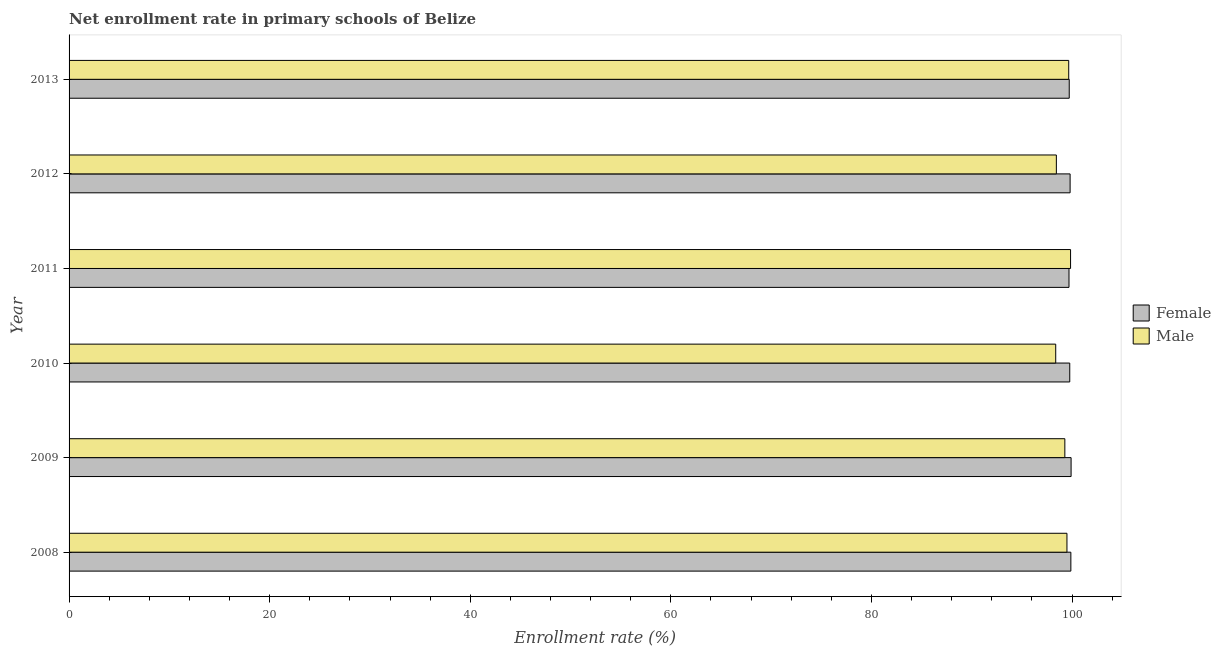How many bars are there on the 2nd tick from the top?
Keep it short and to the point. 2. What is the enrollment rate of male students in 2012?
Your response must be concise. 98.44. Across all years, what is the maximum enrollment rate of male students?
Ensure brevity in your answer.  99.85. Across all years, what is the minimum enrollment rate of male students?
Your answer should be compact. 98.37. In which year was the enrollment rate of female students maximum?
Provide a succinct answer. 2009. What is the total enrollment rate of female students in the graph?
Offer a very short reply. 598.79. What is the difference between the enrollment rate of female students in 2009 and that in 2012?
Offer a very short reply. 0.1. What is the difference between the enrollment rate of female students in 2010 and the enrollment rate of male students in 2008?
Your answer should be very brief. 0.28. What is the average enrollment rate of female students per year?
Your answer should be compact. 99.8. What is the ratio of the enrollment rate of male students in 2008 to that in 2013?
Your answer should be very brief. 1. Is the enrollment rate of male students in 2011 less than that in 2012?
Keep it short and to the point. No. What is the difference between the highest and the second highest enrollment rate of male students?
Offer a terse response. 0.18. What is the difference between the highest and the lowest enrollment rate of female students?
Your answer should be compact. 0.21. In how many years, is the enrollment rate of male students greater than the average enrollment rate of male students taken over all years?
Provide a short and direct response. 4. Is the sum of the enrollment rate of male students in 2009 and 2012 greater than the maximum enrollment rate of female students across all years?
Give a very brief answer. Yes. How many bars are there?
Offer a very short reply. 12. Are all the bars in the graph horizontal?
Provide a succinct answer. Yes. How many years are there in the graph?
Ensure brevity in your answer.  6. Are the values on the major ticks of X-axis written in scientific E-notation?
Offer a terse response. No. Does the graph contain any zero values?
Your answer should be compact. No. Does the graph contain grids?
Your answer should be compact. No. Where does the legend appear in the graph?
Keep it short and to the point. Center right. What is the title of the graph?
Make the answer very short. Net enrollment rate in primary schools of Belize. What is the label or title of the X-axis?
Give a very brief answer. Enrollment rate (%). What is the label or title of the Y-axis?
Provide a succinct answer. Year. What is the Enrollment rate (%) in Female in 2008?
Ensure brevity in your answer.  99.88. What is the Enrollment rate (%) in Male in 2008?
Provide a succinct answer. 99.49. What is the Enrollment rate (%) in Female in 2009?
Provide a succinct answer. 99.91. What is the Enrollment rate (%) in Male in 2009?
Offer a terse response. 99.28. What is the Enrollment rate (%) in Female in 2010?
Give a very brief answer. 99.77. What is the Enrollment rate (%) of Male in 2010?
Your answer should be very brief. 98.37. What is the Enrollment rate (%) in Female in 2011?
Offer a terse response. 99.7. What is the Enrollment rate (%) of Male in 2011?
Provide a short and direct response. 99.85. What is the Enrollment rate (%) in Female in 2012?
Your answer should be very brief. 99.81. What is the Enrollment rate (%) in Male in 2012?
Keep it short and to the point. 98.44. What is the Enrollment rate (%) of Female in 2013?
Offer a very short reply. 99.72. What is the Enrollment rate (%) of Male in 2013?
Make the answer very short. 99.67. Across all years, what is the maximum Enrollment rate (%) of Female?
Your answer should be very brief. 99.91. Across all years, what is the maximum Enrollment rate (%) in Male?
Your answer should be compact. 99.85. Across all years, what is the minimum Enrollment rate (%) of Female?
Give a very brief answer. 99.7. Across all years, what is the minimum Enrollment rate (%) in Male?
Offer a terse response. 98.37. What is the total Enrollment rate (%) of Female in the graph?
Offer a very short reply. 598.79. What is the total Enrollment rate (%) of Male in the graph?
Offer a terse response. 595.11. What is the difference between the Enrollment rate (%) of Female in 2008 and that in 2009?
Ensure brevity in your answer.  -0.02. What is the difference between the Enrollment rate (%) in Male in 2008 and that in 2009?
Ensure brevity in your answer.  0.21. What is the difference between the Enrollment rate (%) in Female in 2008 and that in 2010?
Give a very brief answer. 0.11. What is the difference between the Enrollment rate (%) in Male in 2008 and that in 2010?
Provide a succinct answer. 1.12. What is the difference between the Enrollment rate (%) in Female in 2008 and that in 2011?
Your answer should be very brief. 0.19. What is the difference between the Enrollment rate (%) in Male in 2008 and that in 2011?
Give a very brief answer. -0.36. What is the difference between the Enrollment rate (%) in Female in 2008 and that in 2012?
Make the answer very short. 0.07. What is the difference between the Enrollment rate (%) of Male in 2008 and that in 2012?
Offer a very short reply. 1.05. What is the difference between the Enrollment rate (%) in Female in 2008 and that in 2013?
Offer a very short reply. 0.16. What is the difference between the Enrollment rate (%) in Male in 2008 and that in 2013?
Make the answer very short. -0.18. What is the difference between the Enrollment rate (%) in Female in 2009 and that in 2010?
Offer a very short reply. 0.13. What is the difference between the Enrollment rate (%) of Male in 2009 and that in 2010?
Offer a very short reply. 0.91. What is the difference between the Enrollment rate (%) in Female in 2009 and that in 2011?
Provide a succinct answer. 0.21. What is the difference between the Enrollment rate (%) in Male in 2009 and that in 2011?
Your answer should be compact. -0.57. What is the difference between the Enrollment rate (%) of Female in 2009 and that in 2012?
Keep it short and to the point. 0.1. What is the difference between the Enrollment rate (%) of Male in 2009 and that in 2012?
Keep it short and to the point. 0.85. What is the difference between the Enrollment rate (%) in Female in 2009 and that in 2013?
Make the answer very short. 0.19. What is the difference between the Enrollment rate (%) of Male in 2009 and that in 2013?
Provide a short and direct response. -0.39. What is the difference between the Enrollment rate (%) in Female in 2010 and that in 2011?
Give a very brief answer. 0.08. What is the difference between the Enrollment rate (%) in Male in 2010 and that in 2011?
Your answer should be very brief. -1.48. What is the difference between the Enrollment rate (%) of Female in 2010 and that in 2012?
Offer a very short reply. -0.03. What is the difference between the Enrollment rate (%) in Male in 2010 and that in 2012?
Your answer should be very brief. -0.07. What is the difference between the Enrollment rate (%) of Female in 2010 and that in 2013?
Make the answer very short. 0.05. What is the difference between the Enrollment rate (%) of Male in 2010 and that in 2013?
Make the answer very short. -1.3. What is the difference between the Enrollment rate (%) in Female in 2011 and that in 2012?
Provide a short and direct response. -0.11. What is the difference between the Enrollment rate (%) of Male in 2011 and that in 2012?
Your answer should be very brief. 1.42. What is the difference between the Enrollment rate (%) in Female in 2011 and that in 2013?
Make the answer very short. -0.02. What is the difference between the Enrollment rate (%) of Male in 2011 and that in 2013?
Your answer should be compact. 0.18. What is the difference between the Enrollment rate (%) in Female in 2012 and that in 2013?
Ensure brevity in your answer.  0.09. What is the difference between the Enrollment rate (%) in Male in 2012 and that in 2013?
Ensure brevity in your answer.  -1.23. What is the difference between the Enrollment rate (%) in Female in 2008 and the Enrollment rate (%) in Male in 2009?
Offer a terse response. 0.6. What is the difference between the Enrollment rate (%) in Female in 2008 and the Enrollment rate (%) in Male in 2010?
Keep it short and to the point. 1.51. What is the difference between the Enrollment rate (%) in Female in 2008 and the Enrollment rate (%) in Male in 2011?
Your response must be concise. 0.03. What is the difference between the Enrollment rate (%) of Female in 2008 and the Enrollment rate (%) of Male in 2012?
Offer a terse response. 1.44. What is the difference between the Enrollment rate (%) of Female in 2008 and the Enrollment rate (%) of Male in 2013?
Give a very brief answer. 0.21. What is the difference between the Enrollment rate (%) in Female in 2009 and the Enrollment rate (%) in Male in 2010?
Your answer should be compact. 1.53. What is the difference between the Enrollment rate (%) of Female in 2009 and the Enrollment rate (%) of Male in 2011?
Provide a short and direct response. 0.05. What is the difference between the Enrollment rate (%) in Female in 2009 and the Enrollment rate (%) in Male in 2012?
Offer a terse response. 1.47. What is the difference between the Enrollment rate (%) of Female in 2009 and the Enrollment rate (%) of Male in 2013?
Offer a terse response. 0.24. What is the difference between the Enrollment rate (%) in Female in 2010 and the Enrollment rate (%) in Male in 2011?
Your answer should be compact. -0.08. What is the difference between the Enrollment rate (%) of Female in 2010 and the Enrollment rate (%) of Male in 2012?
Provide a succinct answer. 1.33. What is the difference between the Enrollment rate (%) in Female in 2010 and the Enrollment rate (%) in Male in 2013?
Your response must be concise. 0.1. What is the difference between the Enrollment rate (%) of Female in 2011 and the Enrollment rate (%) of Male in 2012?
Your response must be concise. 1.26. What is the difference between the Enrollment rate (%) of Female in 2011 and the Enrollment rate (%) of Male in 2013?
Keep it short and to the point. 0.03. What is the difference between the Enrollment rate (%) of Female in 2012 and the Enrollment rate (%) of Male in 2013?
Your answer should be very brief. 0.14. What is the average Enrollment rate (%) in Female per year?
Your answer should be compact. 99.8. What is the average Enrollment rate (%) in Male per year?
Your answer should be compact. 99.19. In the year 2008, what is the difference between the Enrollment rate (%) of Female and Enrollment rate (%) of Male?
Offer a very short reply. 0.39. In the year 2009, what is the difference between the Enrollment rate (%) of Female and Enrollment rate (%) of Male?
Ensure brevity in your answer.  0.62. In the year 2010, what is the difference between the Enrollment rate (%) of Female and Enrollment rate (%) of Male?
Offer a terse response. 1.4. In the year 2011, what is the difference between the Enrollment rate (%) in Female and Enrollment rate (%) in Male?
Your answer should be very brief. -0.16. In the year 2012, what is the difference between the Enrollment rate (%) in Female and Enrollment rate (%) in Male?
Provide a short and direct response. 1.37. In the year 2013, what is the difference between the Enrollment rate (%) in Female and Enrollment rate (%) in Male?
Make the answer very short. 0.05. What is the ratio of the Enrollment rate (%) of Female in 2008 to that in 2009?
Keep it short and to the point. 1. What is the ratio of the Enrollment rate (%) in Male in 2008 to that in 2009?
Your response must be concise. 1. What is the ratio of the Enrollment rate (%) in Female in 2008 to that in 2010?
Provide a short and direct response. 1. What is the ratio of the Enrollment rate (%) of Male in 2008 to that in 2010?
Your answer should be very brief. 1.01. What is the ratio of the Enrollment rate (%) in Female in 2008 to that in 2011?
Make the answer very short. 1. What is the ratio of the Enrollment rate (%) in Female in 2008 to that in 2012?
Make the answer very short. 1. What is the ratio of the Enrollment rate (%) of Male in 2008 to that in 2012?
Provide a short and direct response. 1.01. What is the ratio of the Enrollment rate (%) in Male in 2008 to that in 2013?
Make the answer very short. 1. What is the ratio of the Enrollment rate (%) in Male in 2009 to that in 2010?
Offer a terse response. 1.01. What is the ratio of the Enrollment rate (%) of Male in 2009 to that in 2012?
Ensure brevity in your answer.  1.01. What is the ratio of the Enrollment rate (%) of Male in 2009 to that in 2013?
Give a very brief answer. 1. What is the ratio of the Enrollment rate (%) of Female in 2010 to that in 2011?
Your answer should be compact. 1. What is the ratio of the Enrollment rate (%) in Male in 2010 to that in 2011?
Make the answer very short. 0.99. What is the ratio of the Enrollment rate (%) in Female in 2010 to that in 2012?
Provide a succinct answer. 1. What is the ratio of the Enrollment rate (%) in Male in 2010 to that in 2012?
Make the answer very short. 1. What is the ratio of the Enrollment rate (%) in Male in 2010 to that in 2013?
Provide a succinct answer. 0.99. What is the ratio of the Enrollment rate (%) in Female in 2011 to that in 2012?
Offer a very short reply. 1. What is the ratio of the Enrollment rate (%) of Male in 2011 to that in 2012?
Keep it short and to the point. 1.01. What is the ratio of the Enrollment rate (%) of Female in 2011 to that in 2013?
Offer a terse response. 1. What is the ratio of the Enrollment rate (%) of Male in 2011 to that in 2013?
Ensure brevity in your answer.  1. What is the ratio of the Enrollment rate (%) in Female in 2012 to that in 2013?
Ensure brevity in your answer.  1. What is the ratio of the Enrollment rate (%) in Male in 2012 to that in 2013?
Your answer should be compact. 0.99. What is the difference between the highest and the second highest Enrollment rate (%) of Female?
Your answer should be compact. 0.02. What is the difference between the highest and the second highest Enrollment rate (%) in Male?
Give a very brief answer. 0.18. What is the difference between the highest and the lowest Enrollment rate (%) of Female?
Make the answer very short. 0.21. What is the difference between the highest and the lowest Enrollment rate (%) in Male?
Your answer should be compact. 1.48. 